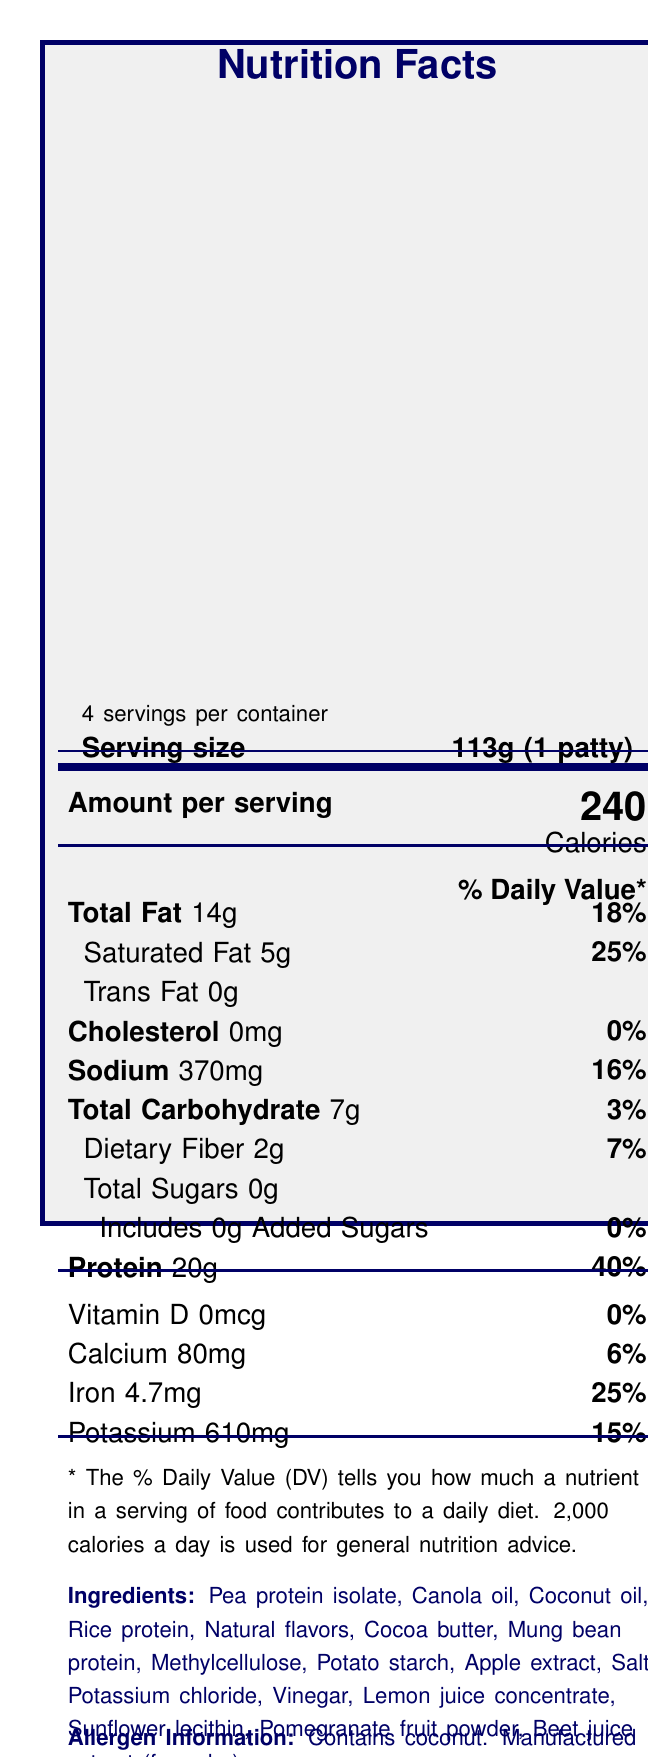what is the serving size? The serving size is clearly stated as "113g (1 patty)" in the document.
Answer: 113g (1 patty) how many servings are in a container? The document states there are 4 servings per container.
Answer: 4 how many calories are in one serving? The calories per serving are listed as 240 in the nutrition facts.
Answer: 240 what is the percentage daily value (% DV) of protein per serving? The % DV of protein per serving is listed as 40%.
Answer: 40% what are the main ingredients of VeggieTech Prime Plant Patty? These ingredients are listed under the "Ingredients" section of the document.
Answer: Pea protein isolate, Canola oil, Coconut oil, Rice protein, Natural flavors, Cocoa butter, Mung bean protein, Methylcellulose, Potato starch, Apple extract, Salt, Potassium chloride, Vinegar, Lemon juice concentrate, Sunflower lecithin, Pomegranate fruit powder, Beet juice extract (for color) what certifications does the product have? A. Non-GMO B. Vegan Certified C. Gluten-Free D. Kosher The product is certified as Non-GMO, Vegan Certified, and Kosher. Gluten-Free is not mentioned.
Answer: A, B, D what is the total fat content per serving? A. 10g B. 14g C. 24g The total fat content per serving is listed as 14g in the document.
Answer: B what is the amino acid composition of the product? A. Lysine - 1.2g B. Methionine - 0.6g C. Leucine - 1.9g Lysine content is 1.2g, Methionine is 0.5g, and Leucine is 1.6g according to the document.
Answer: A is the product recommended for microwave cooking? The cooking instructions state that the product is not recommended for microwave cooking.
Answer: No does the product contain cholesterol? The document states that the cholesterol amount is 0mg.
Answer: No summarize the nutritional benefits and features of VeggieTech Prime Plant Patty. The summary includes all the health benefits and sustainability features mentioned, along with the nutrient profile that makes it a healthy alternative.
Answer: The product is high in protein and iron, cholesterol-free, contains no artificial preservatives, and is soy-free. It has a comprehensive amino acid profile and offers sustainability features like reduced water usage and fewer greenhouse gas emissions. what percentage of greenhouse gas emissions are reduced compared to beef? The sustainability features mention a 90% reduction in greenhouse gas emissions compared to beef.
Answer: 90% what is the manufacturer’s contact number? The manufacturer information section lists the contact number as 1-800-555-VEGI.
Answer: 1-800-555-VEGI what are the storage instructions for the product? The storage instructions specify to keep the product refrigerated below 40°F and use within 3 days of opening.
Answer: Keep refrigerated below 40°F (4°C). Use within 3 days of opening. how much methionine is in one serving? The amino acid profile lists methionine as 0.5g per serving.
Answer: 0.5g which of the following is not an ingredient in VeggieTech Prime Plant Patty? A. Canola oil B. Soy protein C. Mung bean protein D. Beet juice extract Soy protein is not listed as an ingredient. The other ingredients are listed in the document.
Answer: B what is the total carbohydrate content per serving? The nutrition facts list the total carbohydrate content as 7g per serving.
Answer: 7g how much sodium is in one patty? The amount of sodium per serving is listed as 370mg.
Answer: 370mg where is the product manufactured? The country of origin is listed as USA in the document.
Answer: USA what kind of packaging is used for the product? The sustainability features highlight the use of recyclable packaging with 70% post-consumer recycled materials.
Answer: Recyclable packaging made from 70% post-consumer recycled materials which company manufactures the VeggieTech Prime Plant Patty? The manufacturer information section lists EcoProtein Solutions, Inc. as the manufacturer.
Answer: EcoProtein Solutions, Inc. how many milligrams of potassium are present in one serving? The nutrition facts state that there are 610mg of potassium per serving.
Answer: 610mg what is the percentage daily value of dietary fiber in one serving? The nutrition facts list the % DV of dietary fiber as 7%.
Answer: 7% what is the email address for the manufacturer? The document does not provide an email address for the manufacturer.
Answer: Cannot be determined 